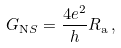Convert formula to latex. <formula><loc_0><loc_0><loc_500><loc_500>G _ { \mathrm N S } = \frac { 4 e ^ { 2 } } { h } R _ { \mathrm a } \, { , }</formula> 